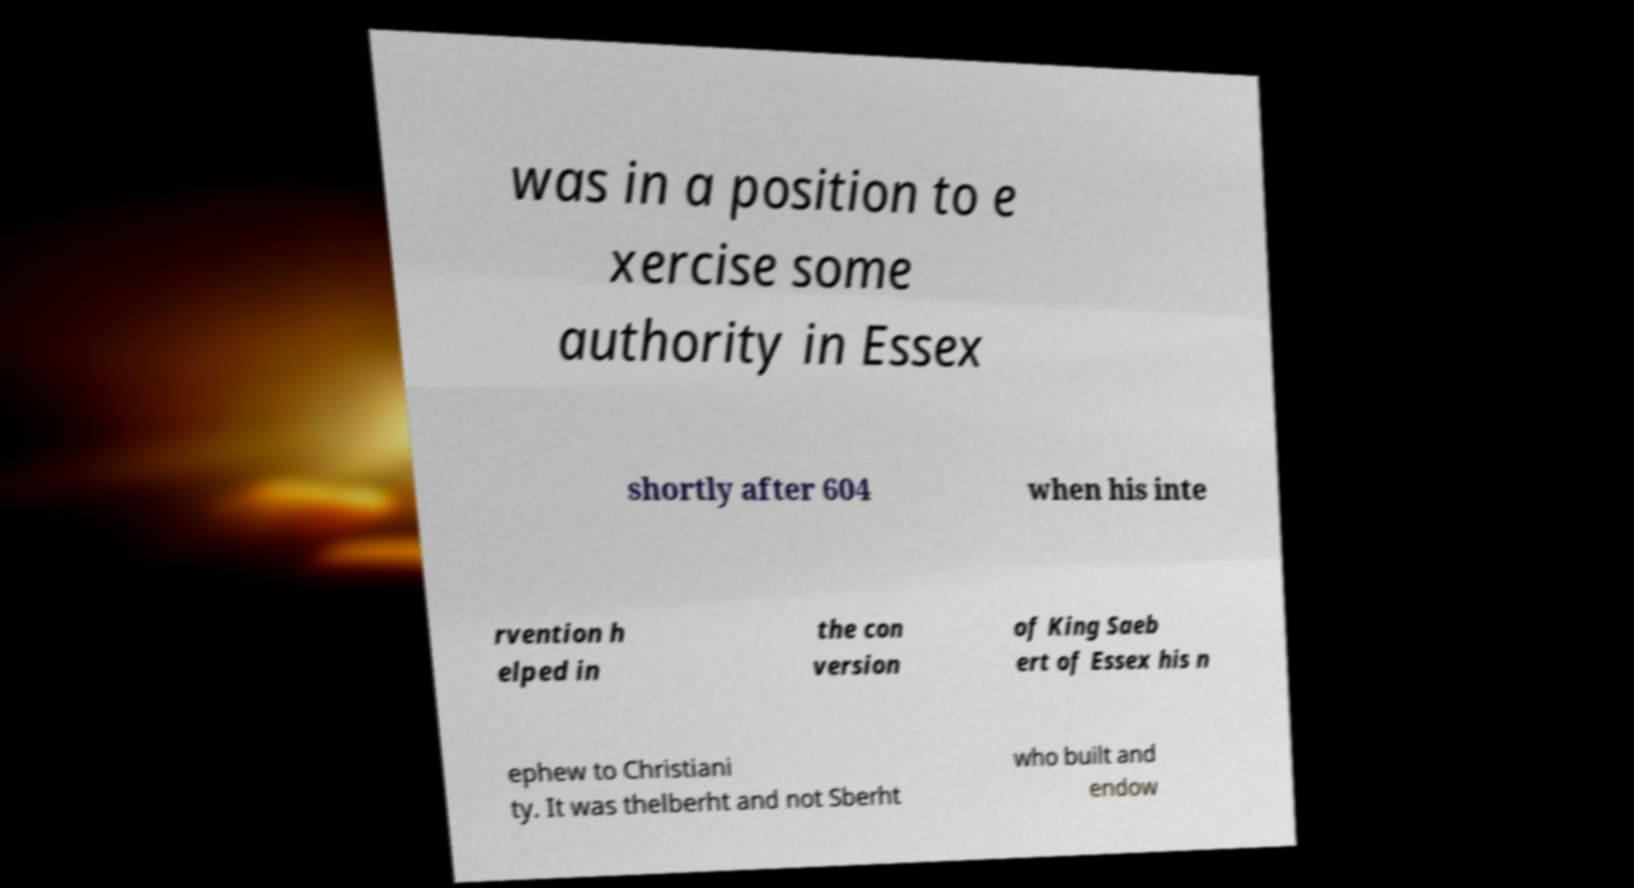There's text embedded in this image that I need extracted. Can you transcribe it verbatim? was in a position to e xercise some authority in Essex shortly after 604 when his inte rvention h elped in the con version of King Saeb ert of Essex his n ephew to Christiani ty. It was thelberht and not Sberht who built and endow 